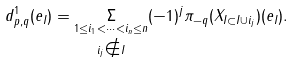<formula> <loc_0><loc_0><loc_500><loc_500>d ^ { 1 } _ { p , q } ( e _ { I } ) = { \underset { i _ { j } \notin I } { { \underset { 1 \leq i _ { 1 } < \cdots < i _ { n } \leq n } { \Sigma } } } } { ( - 1 ) } ^ { j } { \pi } _ { - q } ( X _ { I \subset I \cup i _ { j } } ) ( e _ { I } ) .</formula> 